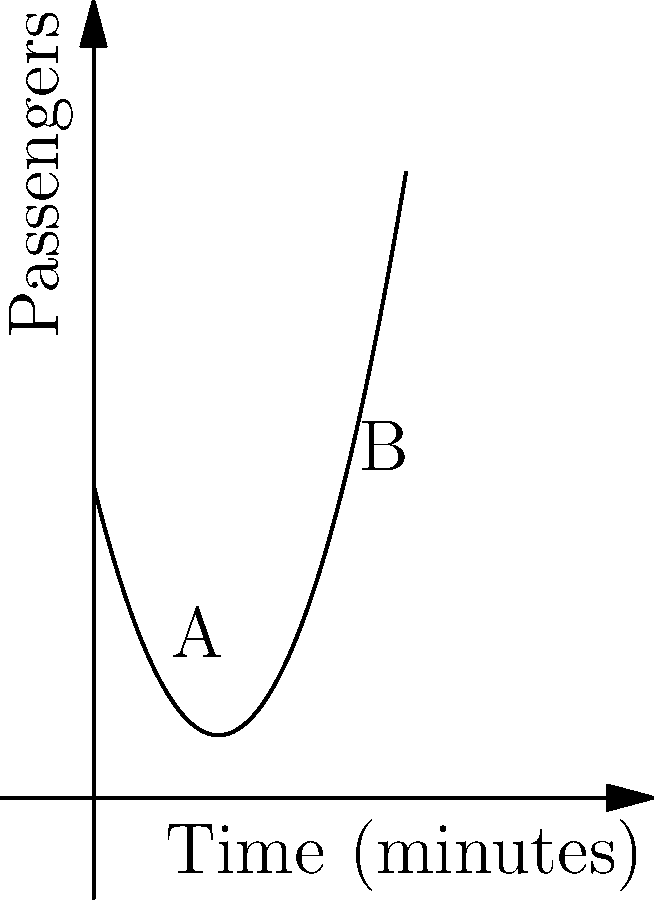As a concerned Melbourne resident, you're analyzing the efficiency of the city's tram system. The curve above represents the number of passengers arriving at a tram stop over time. If $f(t) = 0.5t^2 - 4t + 10$ represents the number of passengers at time $t$ (in minutes), determine the time when the passenger arrival rate is at its minimum. How does this information could be used to optimize tram schedules? To find the minimum arrival rate, we need to find where the derivative of $f(t)$ is zero:

1) First, let's find $f'(t)$:
   $f'(t) = t - 4$

2) Set $f'(t) = 0$ and solve for $t$:
   $t - 4 = 0$
   $t = 4$

3) To confirm this is a minimum (not a maximum), check the second derivative:
   $f''(t) = 1$ (always positive, confirming a minimum)

4) The minimum arrival rate occurs at $t = 4$ minutes.

5) Interpretation for tram scheduling:
   - The slowest passenger arrival rate is at 4 minutes.
   - Before 4 minutes, arrival rate is decreasing; after 4 minutes, it's increasing.
   - To optimize schedules, trams could arrive just after the 4-minute mark to maximize efficiency, catching the increasing flow of passengers.
   - This could lead to less crowding at stops and more efficient use of tram capacity.
Answer: Minimum arrival rate at $t = 4$ minutes; schedule trams after this point for efficiency. 